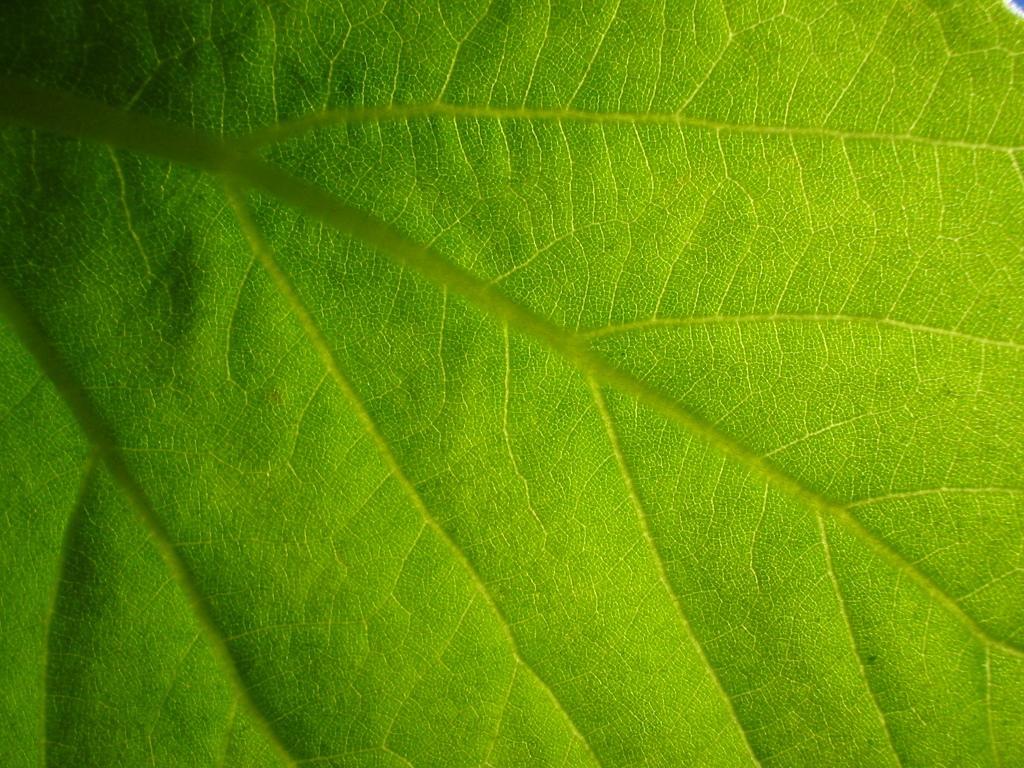Please provide a concise description of this image. In this picture I can see a leaf which is of green in color. 